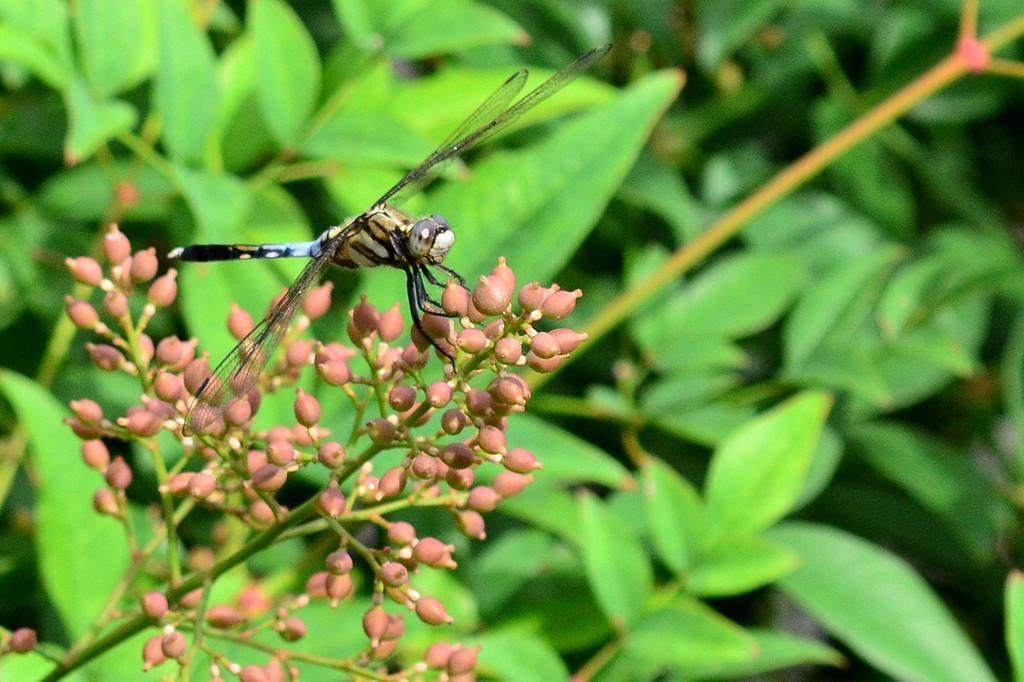Can you describe this image briefly? In this picture we can observe a dragonfly on the flower buds which were in pink color. In the background we can observe some plants which were in green color. 